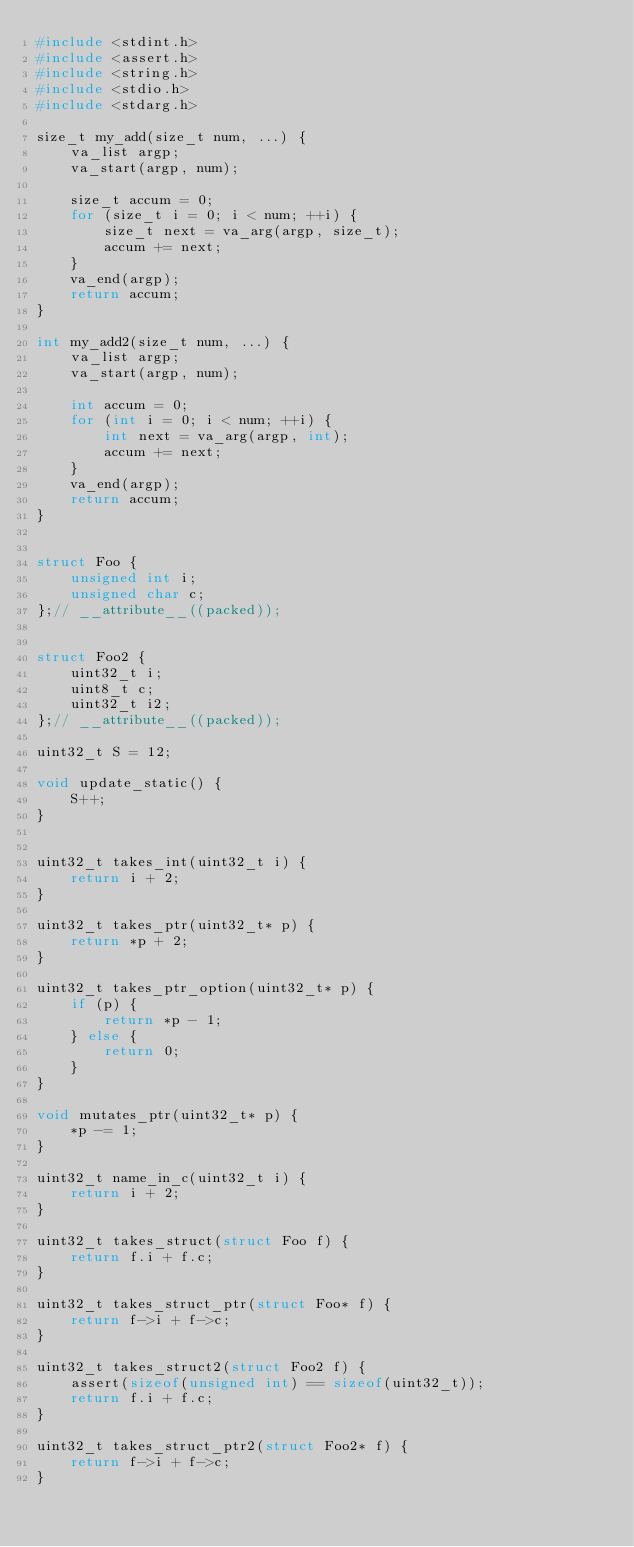<code> <loc_0><loc_0><loc_500><loc_500><_C_>#include <stdint.h>
#include <assert.h>
#include <string.h>
#include <stdio.h>
#include <stdarg.h>

size_t my_add(size_t num, ...) {
    va_list argp;
    va_start(argp, num);

    size_t accum = 0;
    for (size_t i = 0; i < num; ++i) {
        size_t next = va_arg(argp, size_t);
        accum += next;
    }
    va_end(argp);
    return accum;
}

int my_add2(size_t num, ...) {
    va_list argp;
    va_start(argp, num);

    int accum = 0;
    for (int i = 0; i < num; ++i) {
        int next = va_arg(argp, int);
        accum += next;
    }
    va_end(argp);
    return accum;
}


struct Foo {
    unsigned int i;
    unsigned char c;
};// __attribute__((packed));


struct Foo2 {
    uint32_t i;
    uint8_t c;
    uint32_t i2;
};// __attribute__((packed));

uint32_t S = 12;

void update_static() {
    S++;
}


uint32_t takes_int(uint32_t i) {
    return i + 2;
}

uint32_t takes_ptr(uint32_t* p) {
    return *p + 2;
}

uint32_t takes_ptr_option(uint32_t* p) {
    if (p) {
        return *p - 1;
    } else {
        return 0;
    }
}

void mutates_ptr(uint32_t* p) {
    *p -= 1;
}

uint32_t name_in_c(uint32_t i) {
    return i + 2;
}

uint32_t takes_struct(struct Foo f) {
    return f.i + f.c;
}

uint32_t takes_struct_ptr(struct Foo* f) {
    return f->i + f->c;
}

uint32_t takes_struct2(struct Foo2 f) {
    assert(sizeof(unsigned int) == sizeof(uint32_t));
    return f.i + f.c;
}

uint32_t takes_struct_ptr2(struct Foo2* f) {
    return f->i + f->c;
}

</code> 